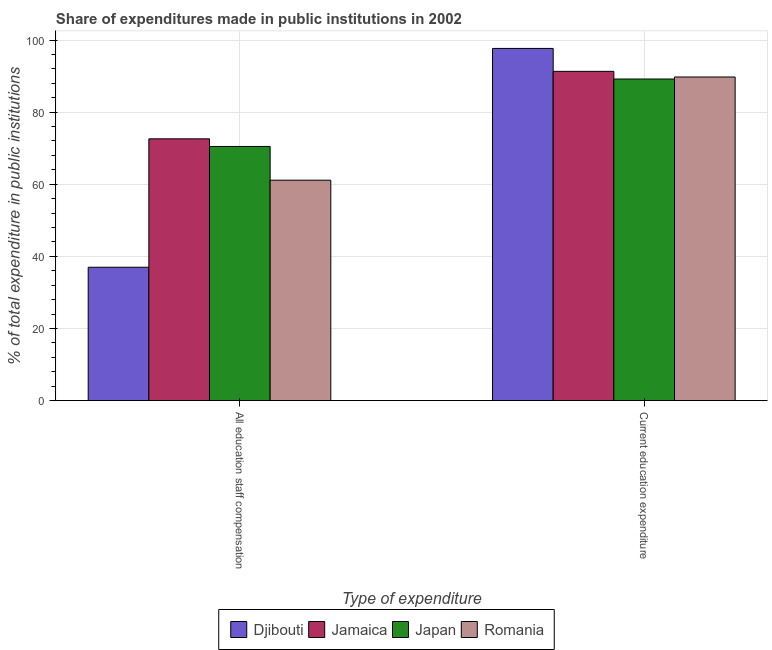Are the number of bars per tick equal to the number of legend labels?
Offer a terse response. Yes. How many bars are there on the 1st tick from the right?
Your answer should be compact. 4. What is the label of the 1st group of bars from the left?
Offer a terse response. All education staff compensation. What is the expenditure in education in Romania?
Make the answer very short. 89.75. Across all countries, what is the maximum expenditure in education?
Give a very brief answer. 97.67. Across all countries, what is the minimum expenditure in education?
Your answer should be compact. 89.19. In which country was the expenditure in education maximum?
Your answer should be very brief. Djibouti. What is the total expenditure in staff compensation in the graph?
Ensure brevity in your answer.  241.19. What is the difference between the expenditure in staff compensation in Japan and that in Romania?
Keep it short and to the point. 9.36. What is the difference between the expenditure in education in Jamaica and the expenditure in staff compensation in Japan?
Make the answer very short. 20.83. What is the average expenditure in staff compensation per country?
Keep it short and to the point. 60.3. What is the difference between the expenditure in staff compensation and expenditure in education in Japan?
Offer a very short reply. -18.71. What is the ratio of the expenditure in education in Romania to that in Djibouti?
Give a very brief answer. 0.92. In how many countries, is the expenditure in education greater than the average expenditure in education taken over all countries?
Ensure brevity in your answer.  1. What does the 2nd bar from the left in All education staff compensation represents?
Your response must be concise. Jamaica. What does the 3rd bar from the right in All education staff compensation represents?
Provide a short and direct response. Jamaica. How many bars are there?
Ensure brevity in your answer.  8. Are all the bars in the graph horizontal?
Make the answer very short. No. Are the values on the major ticks of Y-axis written in scientific E-notation?
Make the answer very short. No. Does the graph contain any zero values?
Give a very brief answer. No. Does the graph contain grids?
Ensure brevity in your answer.  Yes. Where does the legend appear in the graph?
Provide a succinct answer. Bottom center. How many legend labels are there?
Your answer should be compact. 4. What is the title of the graph?
Your response must be concise. Share of expenditures made in public institutions in 2002. Does "Sierra Leone" appear as one of the legend labels in the graph?
Provide a succinct answer. No. What is the label or title of the X-axis?
Offer a very short reply. Type of expenditure. What is the label or title of the Y-axis?
Keep it short and to the point. % of total expenditure in public institutions. What is the % of total expenditure in public institutions of Djibouti in All education staff compensation?
Your answer should be very brief. 36.98. What is the % of total expenditure in public institutions in Jamaica in All education staff compensation?
Ensure brevity in your answer.  72.6. What is the % of total expenditure in public institutions of Japan in All education staff compensation?
Offer a terse response. 70.48. What is the % of total expenditure in public institutions of Romania in All education staff compensation?
Your answer should be compact. 61.13. What is the % of total expenditure in public institutions of Djibouti in Current education expenditure?
Your response must be concise. 97.67. What is the % of total expenditure in public institutions in Jamaica in Current education expenditure?
Make the answer very short. 91.31. What is the % of total expenditure in public institutions in Japan in Current education expenditure?
Offer a very short reply. 89.19. What is the % of total expenditure in public institutions of Romania in Current education expenditure?
Your response must be concise. 89.75. Across all Type of expenditure, what is the maximum % of total expenditure in public institutions in Djibouti?
Offer a very short reply. 97.67. Across all Type of expenditure, what is the maximum % of total expenditure in public institutions in Jamaica?
Keep it short and to the point. 91.31. Across all Type of expenditure, what is the maximum % of total expenditure in public institutions of Japan?
Provide a succinct answer. 89.19. Across all Type of expenditure, what is the maximum % of total expenditure in public institutions in Romania?
Ensure brevity in your answer.  89.75. Across all Type of expenditure, what is the minimum % of total expenditure in public institutions of Djibouti?
Your response must be concise. 36.98. Across all Type of expenditure, what is the minimum % of total expenditure in public institutions of Jamaica?
Ensure brevity in your answer.  72.6. Across all Type of expenditure, what is the minimum % of total expenditure in public institutions of Japan?
Ensure brevity in your answer.  70.48. Across all Type of expenditure, what is the minimum % of total expenditure in public institutions in Romania?
Offer a terse response. 61.13. What is the total % of total expenditure in public institutions in Djibouti in the graph?
Make the answer very short. 134.65. What is the total % of total expenditure in public institutions of Jamaica in the graph?
Your answer should be compact. 163.91. What is the total % of total expenditure in public institutions in Japan in the graph?
Offer a terse response. 159.67. What is the total % of total expenditure in public institutions of Romania in the graph?
Your response must be concise. 150.88. What is the difference between the % of total expenditure in public institutions of Djibouti in All education staff compensation and that in Current education expenditure?
Give a very brief answer. -60.69. What is the difference between the % of total expenditure in public institutions in Jamaica in All education staff compensation and that in Current education expenditure?
Offer a very short reply. -18.71. What is the difference between the % of total expenditure in public institutions of Japan in All education staff compensation and that in Current education expenditure?
Provide a succinct answer. -18.71. What is the difference between the % of total expenditure in public institutions in Romania in All education staff compensation and that in Current education expenditure?
Provide a succinct answer. -28.62. What is the difference between the % of total expenditure in public institutions of Djibouti in All education staff compensation and the % of total expenditure in public institutions of Jamaica in Current education expenditure?
Your response must be concise. -54.33. What is the difference between the % of total expenditure in public institutions in Djibouti in All education staff compensation and the % of total expenditure in public institutions in Japan in Current education expenditure?
Ensure brevity in your answer.  -52.21. What is the difference between the % of total expenditure in public institutions of Djibouti in All education staff compensation and the % of total expenditure in public institutions of Romania in Current education expenditure?
Make the answer very short. -52.77. What is the difference between the % of total expenditure in public institutions in Jamaica in All education staff compensation and the % of total expenditure in public institutions in Japan in Current education expenditure?
Your answer should be compact. -16.59. What is the difference between the % of total expenditure in public institutions of Jamaica in All education staff compensation and the % of total expenditure in public institutions of Romania in Current education expenditure?
Offer a terse response. -17.15. What is the difference between the % of total expenditure in public institutions of Japan in All education staff compensation and the % of total expenditure in public institutions of Romania in Current education expenditure?
Provide a succinct answer. -19.27. What is the average % of total expenditure in public institutions in Djibouti per Type of expenditure?
Your response must be concise. 67.32. What is the average % of total expenditure in public institutions of Jamaica per Type of expenditure?
Ensure brevity in your answer.  81.96. What is the average % of total expenditure in public institutions of Japan per Type of expenditure?
Provide a succinct answer. 79.84. What is the average % of total expenditure in public institutions in Romania per Type of expenditure?
Your answer should be very brief. 75.44. What is the difference between the % of total expenditure in public institutions in Djibouti and % of total expenditure in public institutions in Jamaica in All education staff compensation?
Ensure brevity in your answer.  -35.62. What is the difference between the % of total expenditure in public institutions in Djibouti and % of total expenditure in public institutions in Japan in All education staff compensation?
Provide a succinct answer. -33.5. What is the difference between the % of total expenditure in public institutions of Djibouti and % of total expenditure in public institutions of Romania in All education staff compensation?
Offer a terse response. -24.15. What is the difference between the % of total expenditure in public institutions of Jamaica and % of total expenditure in public institutions of Japan in All education staff compensation?
Provide a succinct answer. 2.12. What is the difference between the % of total expenditure in public institutions in Jamaica and % of total expenditure in public institutions in Romania in All education staff compensation?
Your answer should be very brief. 11.47. What is the difference between the % of total expenditure in public institutions of Japan and % of total expenditure in public institutions of Romania in All education staff compensation?
Offer a very short reply. 9.36. What is the difference between the % of total expenditure in public institutions in Djibouti and % of total expenditure in public institutions in Jamaica in Current education expenditure?
Give a very brief answer. 6.36. What is the difference between the % of total expenditure in public institutions of Djibouti and % of total expenditure in public institutions of Japan in Current education expenditure?
Offer a terse response. 8.48. What is the difference between the % of total expenditure in public institutions in Djibouti and % of total expenditure in public institutions in Romania in Current education expenditure?
Make the answer very short. 7.92. What is the difference between the % of total expenditure in public institutions in Jamaica and % of total expenditure in public institutions in Japan in Current education expenditure?
Make the answer very short. 2.12. What is the difference between the % of total expenditure in public institutions in Jamaica and % of total expenditure in public institutions in Romania in Current education expenditure?
Your answer should be very brief. 1.56. What is the difference between the % of total expenditure in public institutions in Japan and % of total expenditure in public institutions in Romania in Current education expenditure?
Your response must be concise. -0.56. What is the ratio of the % of total expenditure in public institutions in Djibouti in All education staff compensation to that in Current education expenditure?
Ensure brevity in your answer.  0.38. What is the ratio of the % of total expenditure in public institutions in Jamaica in All education staff compensation to that in Current education expenditure?
Your answer should be compact. 0.8. What is the ratio of the % of total expenditure in public institutions in Japan in All education staff compensation to that in Current education expenditure?
Your answer should be very brief. 0.79. What is the ratio of the % of total expenditure in public institutions in Romania in All education staff compensation to that in Current education expenditure?
Offer a very short reply. 0.68. What is the difference between the highest and the second highest % of total expenditure in public institutions in Djibouti?
Make the answer very short. 60.69. What is the difference between the highest and the second highest % of total expenditure in public institutions of Jamaica?
Your answer should be compact. 18.71. What is the difference between the highest and the second highest % of total expenditure in public institutions of Japan?
Your response must be concise. 18.71. What is the difference between the highest and the second highest % of total expenditure in public institutions in Romania?
Your response must be concise. 28.62. What is the difference between the highest and the lowest % of total expenditure in public institutions in Djibouti?
Provide a short and direct response. 60.69. What is the difference between the highest and the lowest % of total expenditure in public institutions in Jamaica?
Keep it short and to the point. 18.71. What is the difference between the highest and the lowest % of total expenditure in public institutions of Japan?
Make the answer very short. 18.71. What is the difference between the highest and the lowest % of total expenditure in public institutions of Romania?
Offer a terse response. 28.62. 